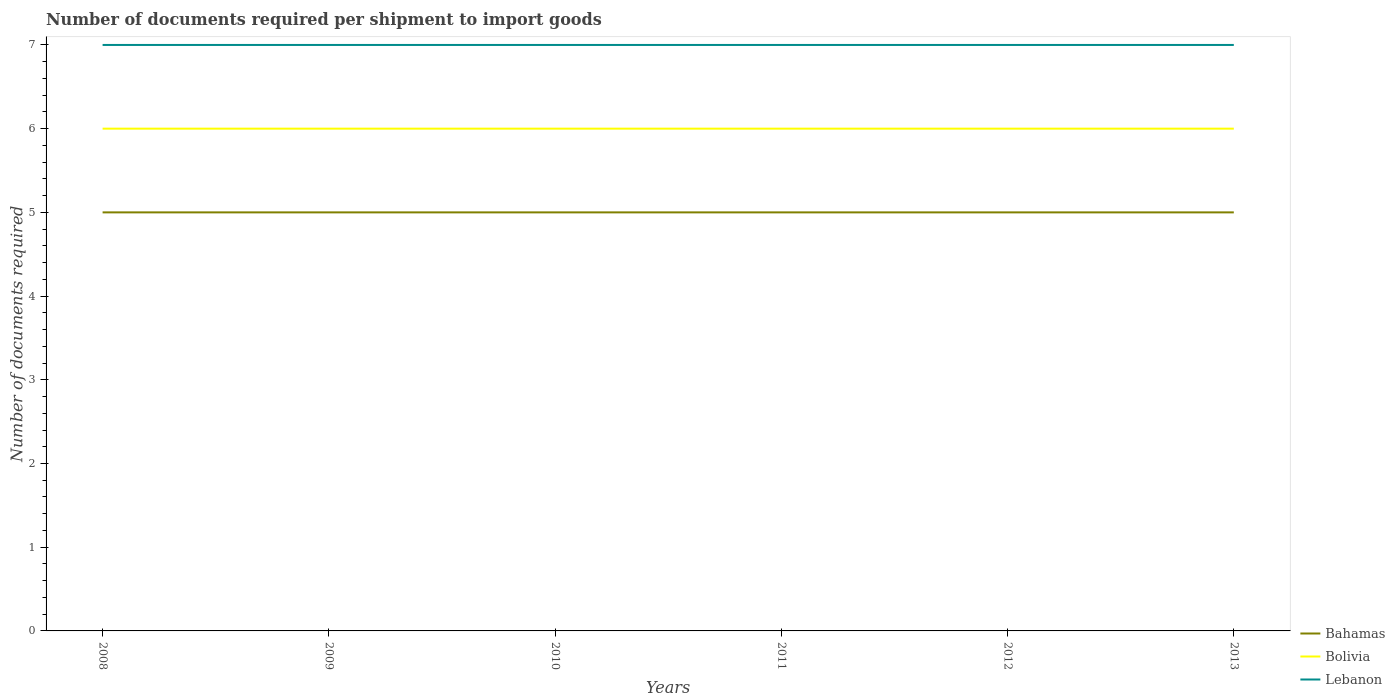Does the line corresponding to Bolivia intersect with the line corresponding to Lebanon?
Give a very brief answer. No. Across all years, what is the maximum number of documents required per shipment to import goods in Bahamas?
Make the answer very short. 5. What is the total number of documents required per shipment to import goods in Bolivia in the graph?
Offer a very short reply. 0. What is the difference between the highest and the second highest number of documents required per shipment to import goods in Lebanon?
Keep it short and to the point. 0. Is the number of documents required per shipment to import goods in Lebanon strictly greater than the number of documents required per shipment to import goods in Bahamas over the years?
Provide a succinct answer. No. How many lines are there?
Your answer should be compact. 3. Are the values on the major ticks of Y-axis written in scientific E-notation?
Your answer should be compact. No. Where does the legend appear in the graph?
Offer a very short reply. Bottom right. How are the legend labels stacked?
Provide a short and direct response. Vertical. What is the title of the graph?
Your response must be concise. Number of documents required per shipment to import goods. Does "Liberia" appear as one of the legend labels in the graph?
Keep it short and to the point. No. What is the label or title of the X-axis?
Ensure brevity in your answer.  Years. What is the label or title of the Y-axis?
Keep it short and to the point. Number of documents required. What is the Number of documents required in Bahamas in 2008?
Your answer should be compact. 5. What is the Number of documents required of Lebanon in 2009?
Keep it short and to the point. 7. What is the Number of documents required in Bolivia in 2010?
Offer a terse response. 6. What is the Number of documents required of Lebanon in 2010?
Your answer should be compact. 7. What is the Number of documents required of Bahamas in 2011?
Offer a very short reply. 5. What is the Number of documents required of Lebanon in 2011?
Your answer should be compact. 7. What is the Number of documents required in Bolivia in 2012?
Provide a succinct answer. 6. What is the Number of documents required in Lebanon in 2012?
Make the answer very short. 7. Across all years, what is the maximum Number of documents required of Lebanon?
Offer a terse response. 7. Across all years, what is the minimum Number of documents required in Bahamas?
Give a very brief answer. 5. Across all years, what is the minimum Number of documents required of Bolivia?
Your response must be concise. 6. What is the difference between the Number of documents required of Bahamas in 2008 and that in 2010?
Ensure brevity in your answer.  0. What is the difference between the Number of documents required in Bahamas in 2008 and that in 2011?
Ensure brevity in your answer.  0. What is the difference between the Number of documents required in Bolivia in 2008 and that in 2011?
Your response must be concise. 0. What is the difference between the Number of documents required of Lebanon in 2008 and that in 2011?
Your answer should be very brief. 0. What is the difference between the Number of documents required in Bahamas in 2008 and that in 2012?
Keep it short and to the point. 0. What is the difference between the Number of documents required in Bolivia in 2008 and that in 2012?
Your answer should be very brief. 0. What is the difference between the Number of documents required of Bahamas in 2008 and that in 2013?
Keep it short and to the point. 0. What is the difference between the Number of documents required of Bolivia in 2008 and that in 2013?
Your response must be concise. 0. What is the difference between the Number of documents required in Bahamas in 2009 and that in 2010?
Offer a very short reply. 0. What is the difference between the Number of documents required of Bolivia in 2009 and that in 2010?
Your response must be concise. 0. What is the difference between the Number of documents required of Lebanon in 2009 and that in 2010?
Keep it short and to the point. 0. What is the difference between the Number of documents required of Bolivia in 2009 and that in 2011?
Provide a short and direct response. 0. What is the difference between the Number of documents required of Lebanon in 2009 and that in 2011?
Give a very brief answer. 0. What is the difference between the Number of documents required in Bolivia in 2009 and that in 2012?
Ensure brevity in your answer.  0. What is the difference between the Number of documents required of Bahamas in 2009 and that in 2013?
Offer a very short reply. 0. What is the difference between the Number of documents required of Bolivia in 2009 and that in 2013?
Your response must be concise. 0. What is the difference between the Number of documents required of Lebanon in 2009 and that in 2013?
Provide a short and direct response. 0. What is the difference between the Number of documents required of Bahamas in 2010 and that in 2011?
Provide a succinct answer. 0. What is the difference between the Number of documents required in Bolivia in 2010 and that in 2012?
Your response must be concise. 0. What is the difference between the Number of documents required in Bahamas in 2010 and that in 2013?
Keep it short and to the point. 0. What is the difference between the Number of documents required in Bolivia in 2010 and that in 2013?
Provide a succinct answer. 0. What is the difference between the Number of documents required in Bahamas in 2012 and that in 2013?
Your answer should be very brief. 0. What is the difference between the Number of documents required of Bolivia in 2012 and that in 2013?
Keep it short and to the point. 0. What is the difference between the Number of documents required of Lebanon in 2012 and that in 2013?
Provide a short and direct response. 0. What is the difference between the Number of documents required in Bahamas in 2008 and the Number of documents required in Bolivia in 2009?
Your answer should be compact. -1. What is the difference between the Number of documents required in Bahamas in 2008 and the Number of documents required in Bolivia in 2011?
Keep it short and to the point. -1. What is the difference between the Number of documents required in Bahamas in 2008 and the Number of documents required in Bolivia in 2012?
Your answer should be compact. -1. What is the difference between the Number of documents required in Bahamas in 2008 and the Number of documents required in Bolivia in 2013?
Provide a succinct answer. -1. What is the difference between the Number of documents required in Bahamas in 2008 and the Number of documents required in Lebanon in 2013?
Make the answer very short. -2. What is the difference between the Number of documents required of Bolivia in 2008 and the Number of documents required of Lebanon in 2013?
Provide a succinct answer. -1. What is the difference between the Number of documents required of Bahamas in 2009 and the Number of documents required of Bolivia in 2010?
Offer a very short reply. -1. What is the difference between the Number of documents required in Bahamas in 2009 and the Number of documents required in Lebanon in 2010?
Your answer should be very brief. -2. What is the difference between the Number of documents required of Bolivia in 2009 and the Number of documents required of Lebanon in 2010?
Give a very brief answer. -1. What is the difference between the Number of documents required in Bahamas in 2009 and the Number of documents required in Bolivia in 2011?
Offer a very short reply. -1. What is the difference between the Number of documents required of Bolivia in 2009 and the Number of documents required of Lebanon in 2011?
Your answer should be compact. -1. What is the difference between the Number of documents required of Bahamas in 2009 and the Number of documents required of Bolivia in 2012?
Ensure brevity in your answer.  -1. What is the difference between the Number of documents required in Bahamas in 2009 and the Number of documents required in Lebanon in 2012?
Make the answer very short. -2. What is the difference between the Number of documents required of Bahamas in 2009 and the Number of documents required of Bolivia in 2013?
Provide a short and direct response. -1. What is the difference between the Number of documents required of Bolivia in 2009 and the Number of documents required of Lebanon in 2013?
Your response must be concise. -1. What is the difference between the Number of documents required in Bahamas in 2010 and the Number of documents required in Bolivia in 2011?
Your answer should be compact. -1. What is the difference between the Number of documents required in Bahamas in 2010 and the Number of documents required in Bolivia in 2012?
Keep it short and to the point. -1. What is the difference between the Number of documents required in Bahamas in 2010 and the Number of documents required in Lebanon in 2013?
Your answer should be very brief. -2. What is the difference between the Number of documents required in Bolivia in 2010 and the Number of documents required in Lebanon in 2013?
Keep it short and to the point. -1. What is the difference between the Number of documents required of Bahamas in 2011 and the Number of documents required of Bolivia in 2012?
Offer a terse response. -1. What is the difference between the Number of documents required in Bahamas in 2011 and the Number of documents required in Lebanon in 2012?
Provide a short and direct response. -2. What is the difference between the Number of documents required of Bahamas in 2011 and the Number of documents required of Bolivia in 2013?
Your answer should be compact. -1. What is the difference between the Number of documents required of Bahamas in 2011 and the Number of documents required of Lebanon in 2013?
Your answer should be compact. -2. What is the difference between the Number of documents required in Bahamas in 2012 and the Number of documents required in Bolivia in 2013?
Your answer should be compact. -1. What is the average Number of documents required of Bahamas per year?
Offer a terse response. 5. What is the average Number of documents required of Bolivia per year?
Your answer should be very brief. 6. In the year 2008, what is the difference between the Number of documents required in Bahamas and Number of documents required in Lebanon?
Ensure brevity in your answer.  -2. In the year 2010, what is the difference between the Number of documents required in Bahamas and Number of documents required in Bolivia?
Ensure brevity in your answer.  -1. In the year 2010, what is the difference between the Number of documents required of Bahamas and Number of documents required of Lebanon?
Ensure brevity in your answer.  -2. In the year 2010, what is the difference between the Number of documents required of Bolivia and Number of documents required of Lebanon?
Offer a terse response. -1. In the year 2011, what is the difference between the Number of documents required in Bahamas and Number of documents required in Bolivia?
Provide a short and direct response. -1. In the year 2012, what is the difference between the Number of documents required of Bahamas and Number of documents required of Bolivia?
Make the answer very short. -1. In the year 2012, what is the difference between the Number of documents required in Bahamas and Number of documents required in Lebanon?
Keep it short and to the point. -2. In the year 2013, what is the difference between the Number of documents required in Bahamas and Number of documents required in Bolivia?
Provide a short and direct response. -1. In the year 2013, what is the difference between the Number of documents required in Bahamas and Number of documents required in Lebanon?
Give a very brief answer. -2. In the year 2013, what is the difference between the Number of documents required of Bolivia and Number of documents required of Lebanon?
Provide a short and direct response. -1. What is the ratio of the Number of documents required of Bahamas in 2008 to that in 2009?
Your answer should be compact. 1. What is the ratio of the Number of documents required of Bolivia in 2008 to that in 2009?
Make the answer very short. 1. What is the ratio of the Number of documents required of Bolivia in 2008 to that in 2011?
Keep it short and to the point. 1. What is the ratio of the Number of documents required of Lebanon in 2008 to that in 2011?
Provide a short and direct response. 1. What is the ratio of the Number of documents required in Bahamas in 2008 to that in 2012?
Ensure brevity in your answer.  1. What is the ratio of the Number of documents required in Bolivia in 2008 to that in 2012?
Offer a terse response. 1. What is the ratio of the Number of documents required in Lebanon in 2008 to that in 2012?
Ensure brevity in your answer.  1. What is the ratio of the Number of documents required of Lebanon in 2008 to that in 2013?
Make the answer very short. 1. What is the ratio of the Number of documents required of Bahamas in 2009 to that in 2011?
Your answer should be compact. 1. What is the ratio of the Number of documents required of Lebanon in 2009 to that in 2011?
Your answer should be very brief. 1. What is the ratio of the Number of documents required of Bolivia in 2009 to that in 2013?
Give a very brief answer. 1. What is the ratio of the Number of documents required in Lebanon in 2009 to that in 2013?
Keep it short and to the point. 1. What is the ratio of the Number of documents required in Bahamas in 2010 to that in 2011?
Your answer should be compact. 1. What is the ratio of the Number of documents required in Lebanon in 2010 to that in 2011?
Your response must be concise. 1. What is the ratio of the Number of documents required of Lebanon in 2010 to that in 2012?
Your response must be concise. 1. What is the ratio of the Number of documents required in Bahamas in 2011 to that in 2012?
Offer a terse response. 1. What is the ratio of the Number of documents required in Bolivia in 2011 to that in 2012?
Your response must be concise. 1. What is the ratio of the Number of documents required of Lebanon in 2011 to that in 2013?
Offer a terse response. 1. What is the difference between the highest and the second highest Number of documents required of Bahamas?
Ensure brevity in your answer.  0. What is the difference between the highest and the second highest Number of documents required in Bolivia?
Provide a short and direct response. 0. 